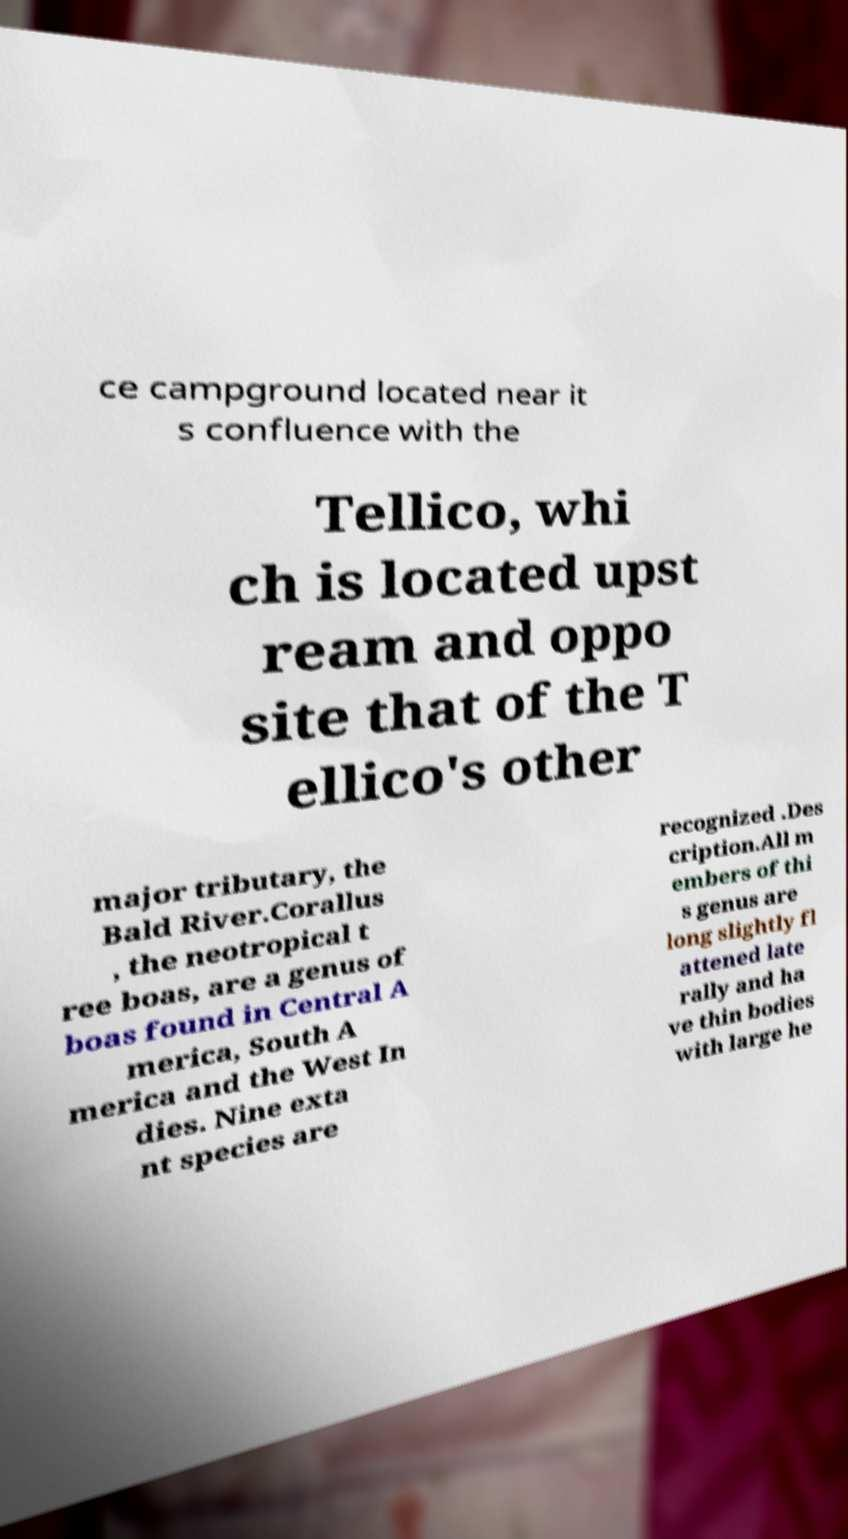For documentation purposes, I need the text within this image transcribed. Could you provide that? ce campground located near it s confluence with the Tellico, whi ch is located upst ream and oppo site that of the T ellico's other major tributary, the Bald River.Corallus , the neotropical t ree boas, are a genus of boas found in Central A merica, South A merica and the West In dies. Nine exta nt species are recognized .Des cription.All m embers of thi s genus are long slightly fl attened late rally and ha ve thin bodies with large he 